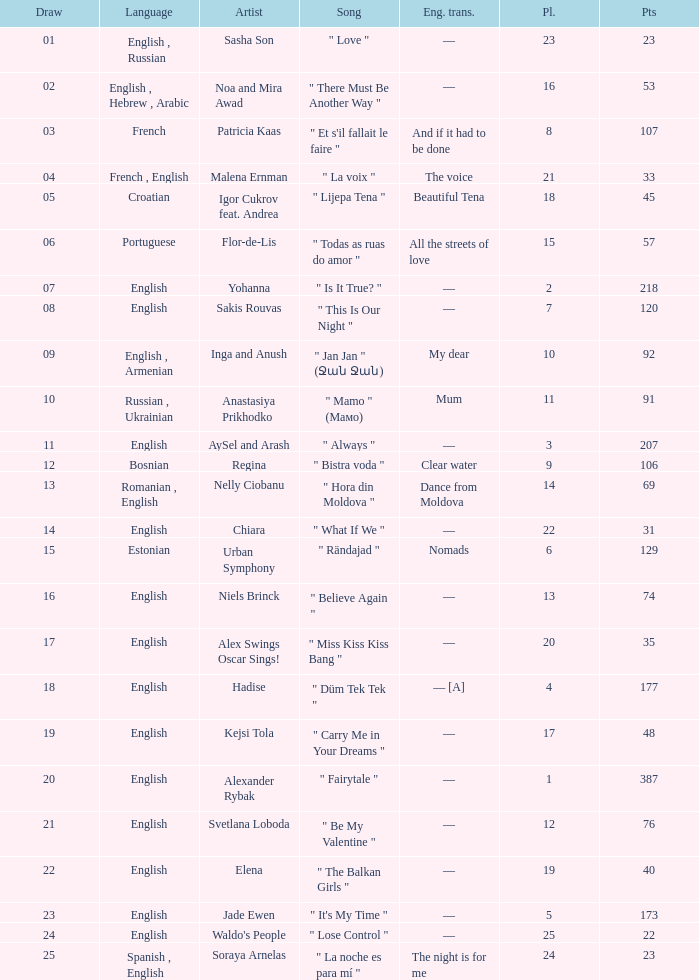What song was in french? " Et s'il fallait le faire ". 